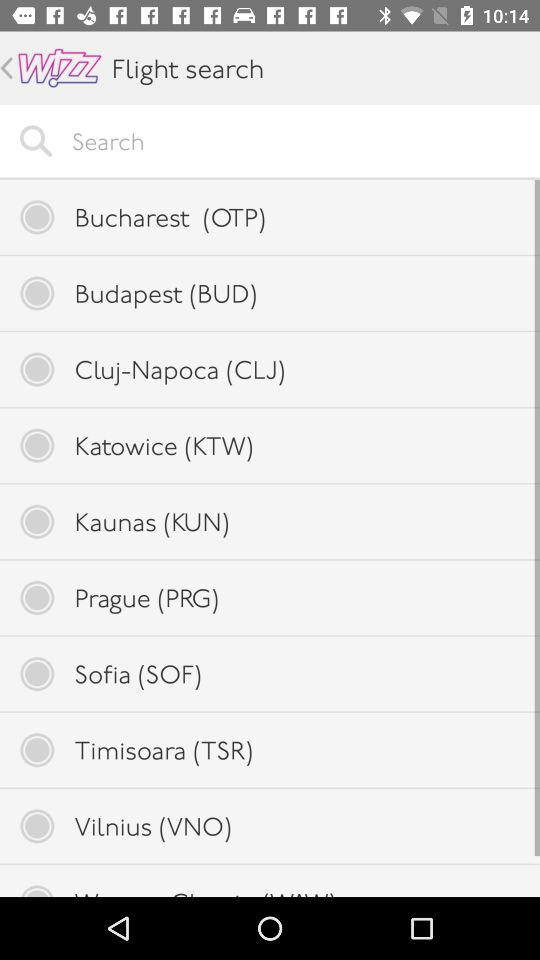What are the available options? The available options are "Bucharest (OTP)", "Budapest (BUD)", "Cluj-Napoca (CLJ)", "Katowice (KTW)", "Kaunas (KUN)", "Prague (PRG)", "Sofia (SOF)", "Timisoara (TSR)" and "Vilnius (VNO)". 